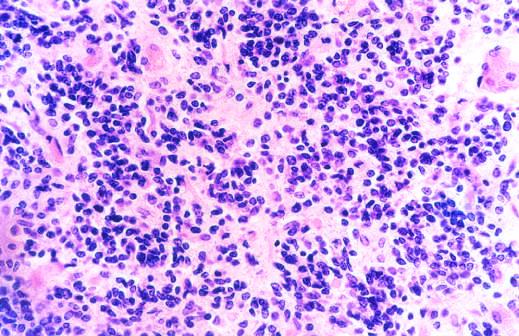did a wide-eyed, staring gaze, caused by overactivity of the sympathetic nervous system, show mostly small, blue, primitive-appearing tumor cells?
Answer the question using a single word or phrase. No 